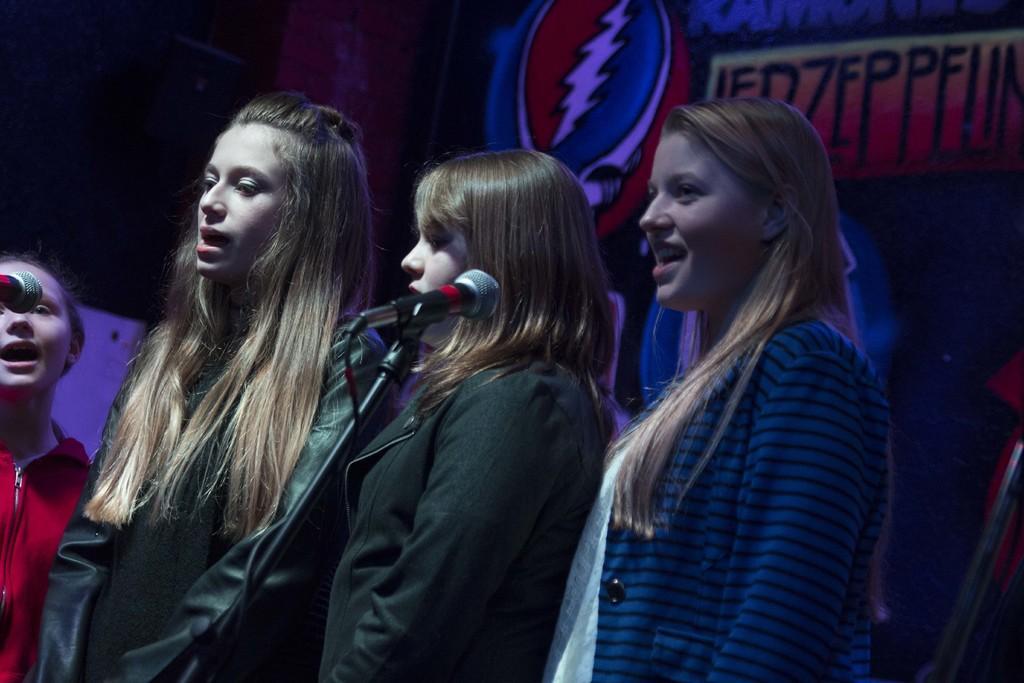How would you summarize this image in a sentence or two? In the image there are four girls standing and singing a song. Behind the girls there is a banner. 